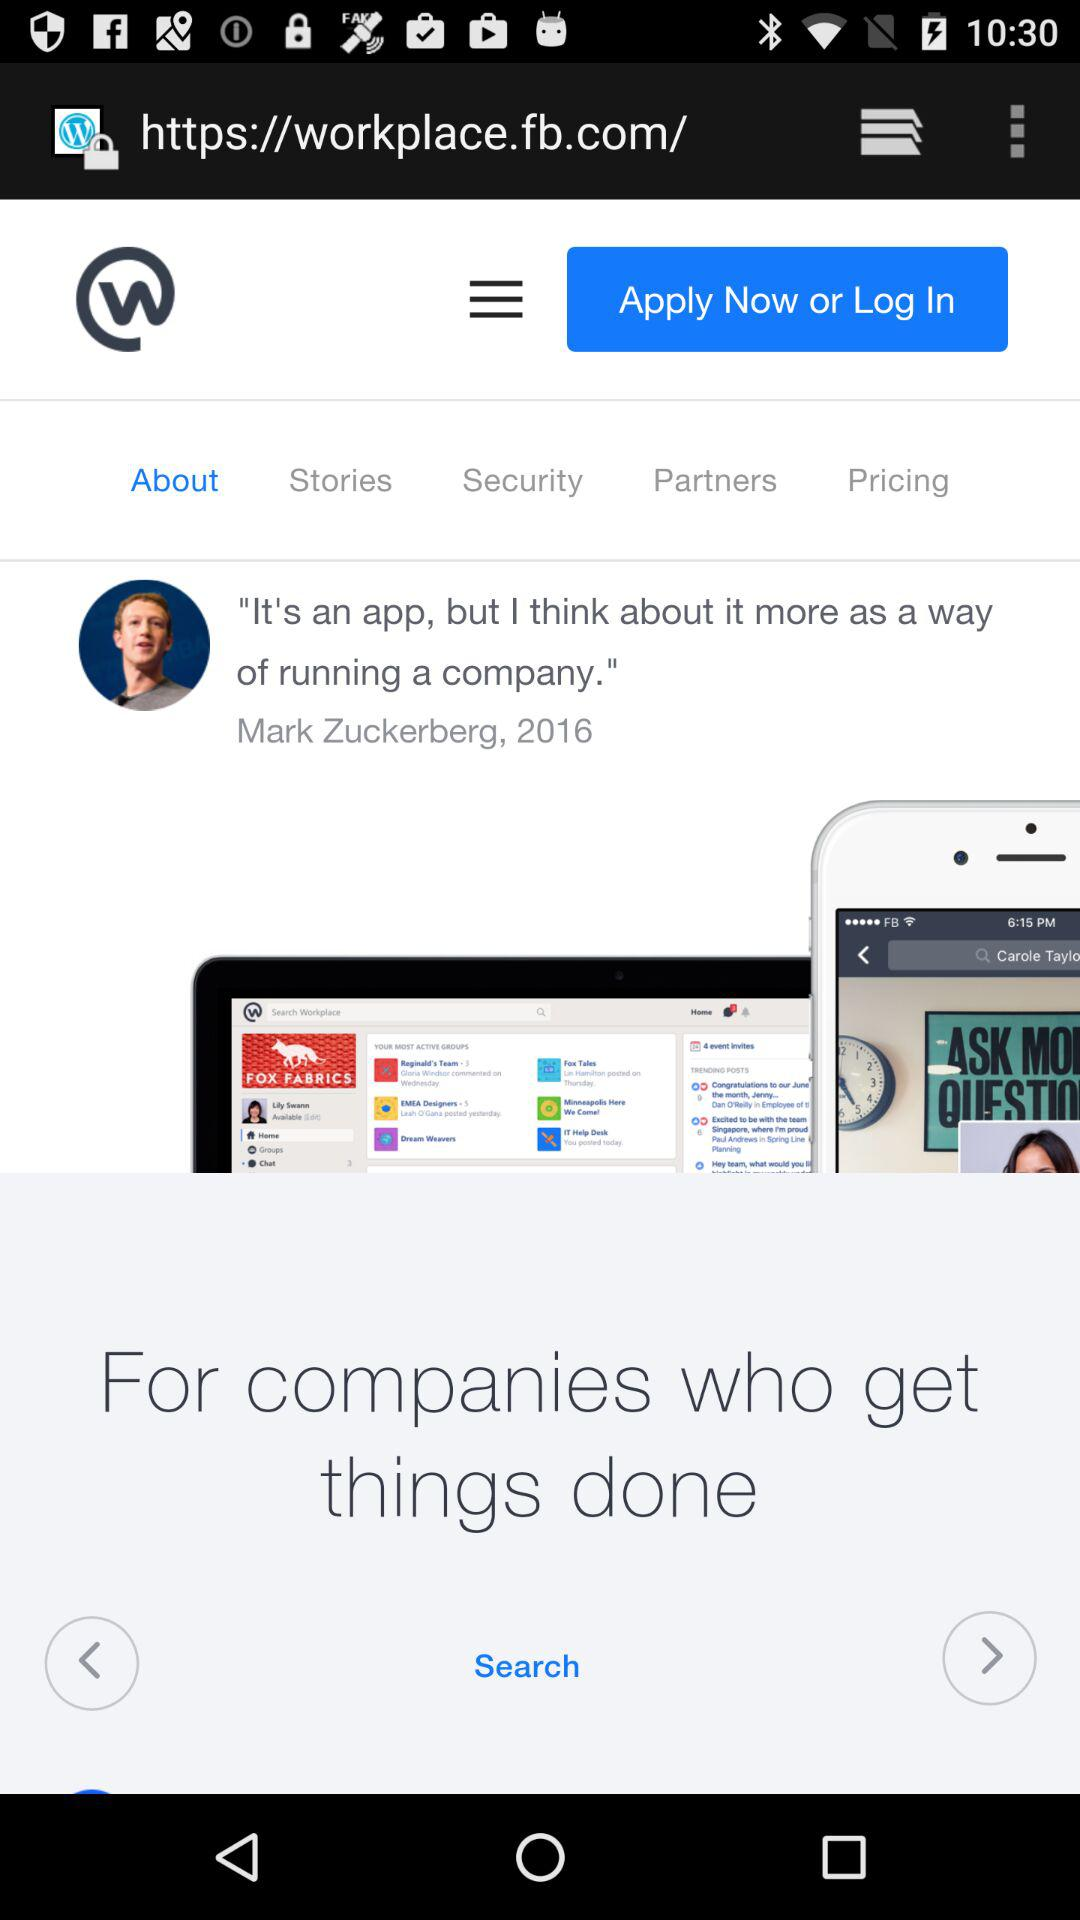What is the name of the application? The name of the application is "Workplace from Meta". 